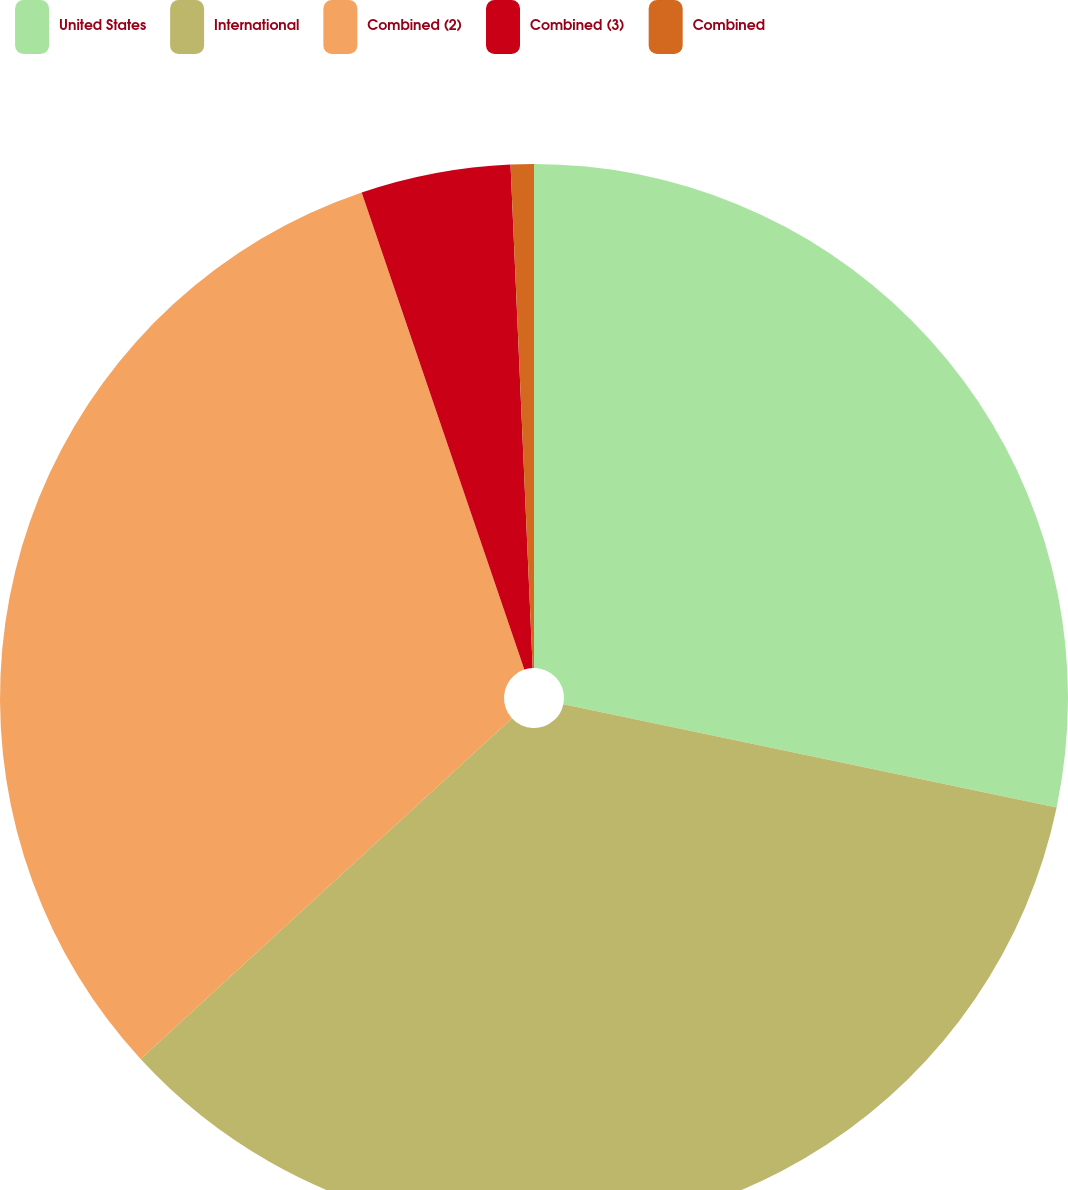Convert chart to OTSL. <chart><loc_0><loc_0><loc_500><loc_500><pie_chart><fcel>United States<fcel>International<fcel>Combined (2)<fcel>Combined (3)<fcel>Combined<nl><fcel>28.29%<fcel>34.89%<fcel>31.59%<fcel>4.53%<fcel>0.7%<nl></chart> 